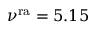<formula> <loc_0><loc_0><loc_500><loc_500>\nu ^ { r a } = 5 . 1 5</formula> 